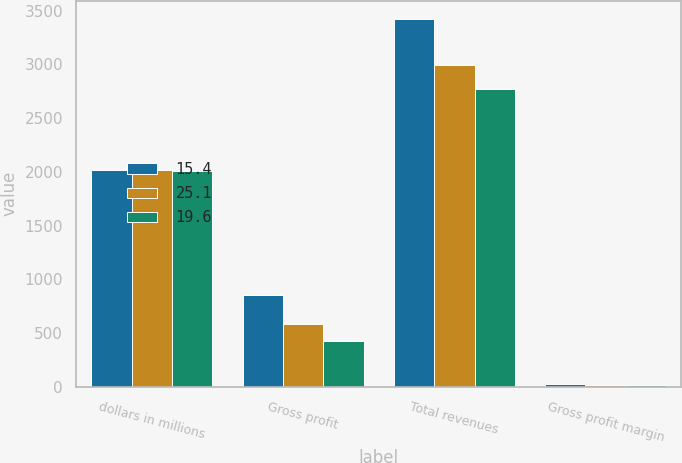<chart> <loc_0><loc_0><loc_500><loc_500><stacked_bar_chart><ecel><fcel>dollars in millions<fcel>Gross profit<fcel>Total revenues<fcel>Gross profit margin<nl><fcel>15.4<fcel>2015<fcel>857.5<fcel>3422.2<fcel>25.1<nl><fcel>25.1<fcel>2014<fcel>587.6<fcel>2994.2<fcel>19.6<nl><fcel>19.6<fcel>2013<fcel>426.9<fcel>2770.7<fcel>15.4<nl></chart> 